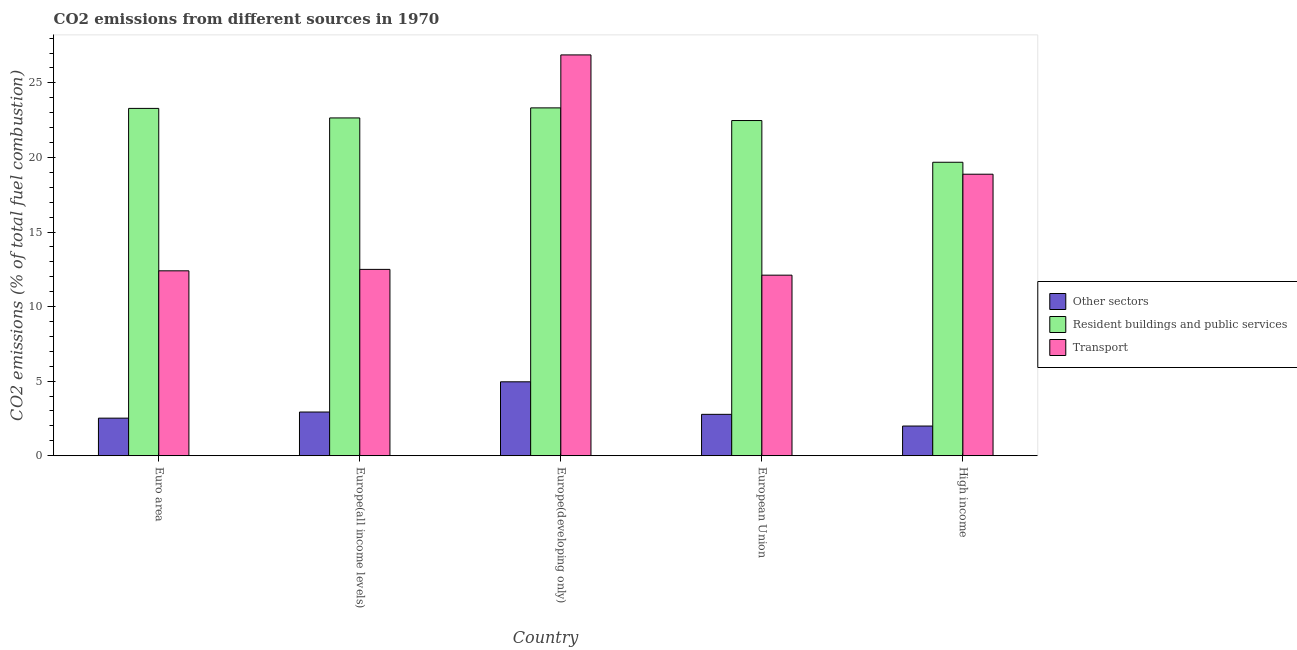How many bars are there on the 3rd tick from the left?
Give a very brief answer. 3. How many bars are there on the 3rd tick from the right?
Keep it short and to the point. 3. In how many cases, is the number of bars for a given country not equal to the number of legend labels?
Make the answer very short. 0. What is the percentage of co2 emissions from other sectors in Euro area?
Ensure brevity in your answer.  2.52. Across all countries, what is the maximum percentage of co2 emissions from transport?
Make the answer very short. 26.88. Across all countries, what is the minimum percentage of co2 emissions from other sectors?
Your answer should be compact. 1.99. In which country was the percentage of co2 emissions from other sectors maximum?
Give a very brief answer. Europe(developing only). In which country was the percentage of co2 emissions from other sectors minimum?
Keep it short and to the point. High income. What is the total percentage of co2 emissions from transport in the graph?
Provide a succinct answer. 82.75. What is the difference between the percentage of co2 emissions from other sectors in Euro area and that in Europe(all income levels)?
Offer a terse response. -0.41. What is the difference between the percentage of co2 emissions from resident buildings and public services in European Union and the percentage of co2 emissions from transport in Europe(all income levels)?
Ensure brevity in your answer.  9.98. What is the average percentage of co2 emissions from other sectors per country?
Keep it short and to the point. 3.03. What is the difference between the percentage of co2 emissions from resident buildings and public services and percentage of co2 emissions from transport in Europe(all income levels)?
Your answer should be compact. 10.16. What is the ratio of the percentage of co2 emissions from other sectors in European Union to that in High income?
Your response must be concise. 1.39. Is the percentage of co2 emissions from resident buildings and public services in Euro area less than that in Europe(developing only)?
Offer a terse response. Yes. Is the difference between the percentage of co2 emissions from resident buildings and public services in Europe(developing only) and European Union greater than the difference between the percentage of co2 emissions from transport in Europe(developing only) and European Union?
Your answer should be very brief. No. What is the difference between the highest and the second highest percentage of co2 emissions from transport?
Keep it short and to the point. 8. What is the difference between the highest and the lowest percentage of co2 emissions from resident buildings and public services?
Keep it short and to the point. 3.65. In how many countries, is the percentage of co2 emissions from resident buildings and public services greater than the average percentage of co2 emissions from resident buildings and public services taken over all countries?
Give a very brief answer. 4. Is the sum of the percentage of co2 emissions from other sectors in European Union and High income greater than the maximum percentage of co2 emissions from transport across all countries?
Your answer should be compact. No. What does the 1st bar from the left in Euro area represents?
Ensure brevity in your answer.  Other sectors. What does the 1st bar from the right in Europe(developing only) represents?
Offer a terse response. Transport. How many bars are there?
Your answer should be compact. 15. Are all the bars in the graph horizontal?
Keep it short and to the point. No. How many countries are there in the graph?
Provide a succinct answer. 5. Does the graph contain grids?
Offer a very short reply. No. Where does the legend appear in the graph?
Provide a succinct answer. Center right. How are the legend labels stacked?
Your answer should be very brief. Vertical. What is the title of the graph?
Ensure brevity in your answer.  CO2 emissions from different sources in 1970. Does "Grants" appear as one of the legend labels in the graph?
Offer a terse response. No. What is the label or title of the X-axis?
Your response must be concise. Country. What is the label or title of the Y-axis?
Keep it short and to the point. CO2 emissions (% of total fuel combustion). What is the CO2 emissions (% of total fuel combustion) of Other sectors in Euro area?
Your answer should be compact. 2.52. What is the CO2 emissions (% of total fuel combustion) of Resident buildings and public services in Euro area?
Make the answer very short. 23.29. What is the CO2 emissions (% of total fuel combustion) of Transport in Euro area?
Offer a very short reply. 12.4. What is the CO2 emissions (% of total fuel combustion) in Other sectors in Europe(all income levels)?
Give a very brief answer. 2.93. What is the CO2 emissions (% of total fuel combustion) in Resident buildings and public services in Europe(all income levels)?
Your answer should be compact. 22.65. What is the CO2 emissions (% of total fuel combustion) in Transport in Europe(all income levels)?
Provide a succinct answer. 12.49. What is the CO2 emissions (% of total fuel combustion) of Other sectors in Europe(developing only)?
Offer a very short reply. 4.96. What is the CO2 emissions (% of total fuel combustion) in Resident buildings and public services in Europe(developing only)?
Give a very brief answer. 23.32. What is the CO2 emissions (% of total fuel combustion) of Transport in Europe(developing only)?
Your answer should be compact. 26.88. What is the CO2 emissions (% of total fuel combustion) of Other sectors in European Union?
Offer a very short reply. 2.78. What is the CO2 emissions (% of total fuel combustion) of Resident buildings and public services in European Union?
Your response must be concise. 22.48. What is the CO2 emissions (% of total fuel combustion) of Transport in European Union?
Offer a terse response. 12.11. What is the CO2 emissions (% of total fuel combustion) in Other sectors in High income?
Offer a very short reply. 1.99. What is the CO2 emissions (% of total fuel combustion) of Resident buildings and public services in High income?
Provide a succinct answer. 19.68. What is the CO2 emissions (% of total fuel combustion) in Transport in High income?
Provide a short and direct response. 18.88. Across all countries, what is the maximum CO2 emissions (% of total fuel combustion) of Other sectors?
Your response must be concise. 4.96. Across all countries, what is the maximum CO2 emissions (% of total fuel combustion) in Resident buildings and public services?
Provide a succinct answer. 23.32. Across all countries, what is the maximum CO2 emissions (% of total fuel combustion) of Transport?
Your response must be concise. 26.88. Across all countries, what is the minimum CO2 emissions (% of total fuel combustion) in Other sectors?
Provide a short and direct response. 1.99. Across all countries, what is the minimum CO2 emissions (% of total fuel combustion) of Resident buildings and public services?
Your answer should be compact. 19.68. Across all countries, what is the minimum CO2 emissions (% of total fuel combustion) in Transport?
Your response must be concise. 12.11. What is the total CO2 emissions (% of total fuel combustion) in Other sectors in the graph?
Offer a very short reply. 15.17. What is the total CO2 emissions (% of total fuel combustion) in Resident buildings and public services in the graph?
Your answer should be compact. 111.42. What is the total CO2 emissions (% of total fuel combustion) in Transport in the graph?
Offer a very short reply. 82.75. What is the difference between the CO2 emissions (% of total fuel combustion) in Other sectors in Euro area and that in Europe(all income levels)?
Your response must be concise. -0.41. What is the difference between the CO2 emissions (% of total fuel combustion) in Resident buildings and public services in Euro area and that in Europe(all income levels)?
Provide a succinct answer. 0.64. What is the difference between the CO2 emissions (% of total fuel combustion) in Transport in Euro area and that in Europe(all income levels)?
Keep it short and to the point. -0.1. What is the difference between the CO2 emissions (% of total fuel combustion) of Other sectors in Euro area and that in Europe(developing only)?
Offer a terse response. -2.44. What is the difference between the CO2 emissions (% of total fuel combustion) in Resident buildings and public services in Euro area and that in Europe(developing only)?
Make the answer very short. -0.03. What is the difference between the CO2 emissions (% of total fuel combustion) of Transport in Euro area and that in Europe(developing only)?
Offer a terse response. -14.48. What is the difference between the CO2 emissions (% of total fuel combustion) of Other sectors in Euro area and that in European Union?
Your response must be concise. -0.26. What is the difference between the CO2 emissions (% of total fuel combustion) of Resident buildings and public services in Euro area and that in European Union?
Provide a short and direct response. 0.81. What is the difference between the CO2 emissions (% of total fuel combustion) of Transport in Euro area and that in European Union?
Your response must be concise. 0.29. What is the difference between the CO2 emissions (% of total fuel combustion) in Other sectors in Euro area and that in High income?
Provide a succinct answer. 0.53. What is the difference between the CO2 emissions (% of total fuel combustion) in Resident buildings and public services in Euro area and that in High income?
Offer a terse response. 3.61. What is the difference between the CO2 emissions (% of total fuel combustion) in Transport in Euro area and that in High income?
Make the answer very short. -6.48. What is the difference between the CO2 emissions (% of total fuel combustion) of Other sectors in Europe(all income levels) and that in Europe(developing only)?
Provide a short and direct response. -2.03. What is the difference between the CO2 emissions (% of total fuel combustion) in Resident buildings and public services in Europe(all income levels) and that in Europe(developing only)?
Offer a terse response. -0.67. What is the difference between the CO2 emissions (% of total fuel combustion) in Transport in Europe(all income levels) and that in Europe(developing only)?
Ensure brevity in your answer.  -14.38. What is the difference between the CO2 emissions (% of total fuel combustion) in Other sectors in Europe(all income levels) and that in European Union?
Offer a very short reply. 0.15. What is the difference between the CO2 emissions (% of total fuel combustion) of Resident buildings and public services in Europe(all income levels) and that in European Union?
Keep it short and to the point. 0.17. What is the difference between the CO2 emissions (% of total fuel combustion) in Transport in Europe(all income levels) and that in European Union?
Your answer should be very brief. 0.39. What is the difference between the CO2 emissions (% of total fuel combustion) in Other sectors in Europe(all income levels) and that in High income?
Your answer should be very brief. 0.94. What is the difference between the CO2 emissions (% of total fuel combustion) of Resident buildings and public services in Europe(all income levels) and that in High income?
Provide a succinct answer. 2.97. What is the difference between the CO2 emissions (% of total fuel combustion) in Transport in Europe(all income levels) and that in High income?
Your answer should be very brief. -6.38. What is the difference between the CO2 emissions (% of total fuel combustion) of Other sectors in Europe(developing only) and that in European Union?
Provide a short and direct response. 2.18. What is the difference between the CO2 emissions (% of total fuel combustion) of Resident buildings and public services in Europe(developing only) and that in European Union?
Provide a short and direct response. 0.85. What is the difference between the CO2 emissions (% of total fuel combustion) of Transport in Europe(developing only) and that in European Union?
Offer a terse response. 14.77. What is the difference between the CO2 emissions (% of total fuel combustion) in Other sectors in Europe(developing only) and that in High income?
Your answer should be compact. 2.97. What is the difference between the CO2 emissions (% of total fuel combustion) in Resident buildings and public services in Europe(developing only) and that in High income?
Keep it short and to the point. 3.65. What is the difference between the CO2 emissions (% of total fuel combustion) of Transport in Europe(developing only) and that in High income?
Provide a short and direct response. 8. What is the difference between the CO2 emissions (% of total fuel combustion) of Other sectors in European Union and that in High income?
Provide a short and direct response. 0.79. What is the difference between the CO2 emissions (% of total fuel combustion) in Resident buildings and public services in European Union and that in High income?
Your answer should be very brief. 2.8. What is the difference between the CO2 emissions (% of total fuel combustion) in Transport in European Union and that in High income?
Give a very brief answer. -6.77. What is the difference between the CO2 emissions (% of total fuel combustion) of Other sectors in Euro area and the CO2 emissions (% of total fuel combustion) of Resident buildings and public services in Europe(all income levels)?
Your response must be concise. -20.13. What is the difference between the CO2 emissions (% of total fuel combustion) in Other sectors in Euro area and the CO2 emissions (% of total fuel combustion) in Transport in Europe(all income levels)?
Offer a very short reply. -9.97. What is the difference between the CO2 emissions (% of total fuel combustion) of Resident buildings and public services in Euro area and the CO2 emissions (% of total fuel combustion) of Transport in Europe(all income levels)?
Your response must be concise. 10.79. What is the difference between the CO2 emissions (% of total fuel combustion) of Other sectors in Euro area and the CO2 emissions (% of total fuel combustion) of Resident buildings and public services in Europe(developing only)?
Keep it short and to the point. -20.8. What is the difference between the CO2 emissions (% of total fuel combustion) in Other sectors in Euro area and the CO2 emissions (% of total fuel combustion) in Transport in Europe(developing only)?
Offer a very short reply. -24.35. What is the difference between the CO2 emissions (% of total fuel combustion) of Resident buildings and public services in Euro area and the CO2 emissions (% of total fuel combustion) of Transport in Europe(developing only)?
Give a very brief answer. -3.59. What is the difference between the CO2 emissions (% of total fuel combustion) of Other sectors in Euro area and the CO2 emissions (% of total fuel combustion) of Resident buildings and public services in European Union?
Give a very brief answer. -19.96. What is the difference between the CO2 emissions (% of total fuel combustion) of Other sectors in Euro area and the CO2 emissions (% of total fuel combustion) of Transport in European Union?
Provide a succinct answer. -9.59. What is the difference between the CO2 emissions (% of total fuel combustion) of Resident buildings and public services in Euro area and the CO2 emissions (% of total fuel combustion) of Transport in European Union?
Make the answer very short. 11.18. What is the difference between the CO2 emissions (% of total fuel combustion) in Other sectors in Euro area and the CO2 emissions (% of total fuel combustion) in Resident buildings and public services in High income?
Offer a very short reply. -17.16. What is the difference between the CO2 emissions (% of total fuel combustion) of Other sectors in Euro area and the CO2 emissions (% of total fuel combustion) of Transport in High income?
Provide a short and direct response. -16.36. What is the difference between the CO2 emissions (% of total fuel combustion) of Resident buildings and public services in Euro area and the CO2 emissions (% of total fuel combustion) of Transport in High income?
Keep it short and to the point. 4.41. What is the difference between the CO2 emissions (% of total fuel combustion) of Other sectors in Europe(all income levels) and the CO2 emissions (% of total fuel combustion) of Resident buildings and public services in Europe(developing only)?
Offer a terse response. -20.39. What is the difference between the CO2 emissions (% of total fuel combustion) in Other sectors in Europe(all income levels) and the CO2 emissions (% of total fuel combustion) in Transport in Europe(developing only)?
Provide a short and direct response. -23.95. What is the difference between the CO2 emissions (% of total fuel combustion) of Resident buildings and public services in Europe(all income levels) and the CO2 emissions (% of total fuel combustion) of Transport in Europe(developing only)?
Keep it short and to the point. -4.23. What is the difference between the CO2 emissions (% of total fuel combustion) in Other sectors in Europe(all income levels) and the CO2 emissions (% of total fuel combustion) in Resident buildings and public services in European Union?
Offer a very short reply. -19.55. What is the difference between the CO2 emissions (% of total fuel combustion) in Other sectors in Europe(all income levels) and the CO2 emissions (% of total fuel combustion) in Transport in European Union?
Provide a succinct answer. -9.18. What is the difference between the CO2 emissions (% of total fuel combustion) of Resident buildings and public services in Europe(all income levels) and the CO2 emissions (% of total fuel combustion) of Transport in European Union?
Provide a succinct answer. 10.54. What is the difference between the CO2 emissions (% of total fuel combustion) of Other sectors in Europe(all income levels) and the CO2 emissions (% of total fuel combustion) of Resident buildings and public services in High income?
Your answer should be compact. -16.75. What is the difference between the CO2 emissions (% of total fuel combustion) of Other sectors in Europe(all income levels) and the CO2 emissions (% of total fuel combustion) of Transport in High income?
Offer a terse response. -15.95. What is the difference between the CO2 emissions (% of total fuel combustion) of Resident buildings and public services in Europe(all income levels) and the CO2 emissions (% of total fuel combustion) of Transport in High income?
Ensure brevity in your answer.  3.77. What is the difference between the CO2 emissions (% of total fuel combustion) in Other sectors in Europe(developing only) and the CO2 emissions (% of total fuel combustion) in Resident buildings and public services in European Union?
Make the answer very short. -17.52. What is the difference between the CO2 emissions (% of total fuel combustion) of Other sectors in Europe(developing only) and the CO2 emissions (% of total fuel combustion) of Transport in European Union?
Keep it short and to the point. -7.15. What is the difference between the CO2 emissions (% of total fuel combustion) of Resident buildings and public services in Europe(developing only) and the CO2 emissions (% of total fuel combustion) of Transport in European Union?
Make the answer very short. 11.22. What is the difference between the CO2 emissions (% of total fuel combustion) of Other sectors in Europe(developing only) and the CO2 emissions (% of total fuel combustion) of Resident buildings and public services in High income?
Your answer should be very brief. -14.72. What is the difference between the CO2 emissions (% of total fuel combustion) of Other sectors in Europe(developing only) and the CO2 emissions (% of total fuel combustion) of Transport in High income?
Your response must be concise. -13.92. What is the difference between the CO2 emissions (% of total fuel combustion) in Resident buildings and public services in Europe(developing only) and the CO2 emissions (% of total fuel combustion) in Transport in High income?
Offer a very short reply. 4.45. What is the difference between the CO2 emissions (% of total fuel combustion) of Other sectors in European Union and the CO2 emissions (% of total fuel combustion) of Resident buildings and public services in High income?
Make the answer very short. -16.9. What is the difference between the CO2 emissions (% of total fuel combustion) of Other sectors in European Union and the CO2 emissions (% of total fuel combustion) of Transport in High income?
Ensure brevity in your answer.  -16.1. What is the difference between the CO2 emissions (% of total fuel combustion) of Resident buildings and public services in European Union and the CO2 emissions (% of total fuel combustion) of Transport in High income?
Provide a succinct answer. 3.6. What is the average CO2 emissions (% of total fuel combustion) of Other sectors per country?
Offer a terse response. 3.03. What is the average CO2 emissions (% of total fuel combustion) of Resident buildings and public services per country?
Offer a very short reply. 22.28. What is the average CO2 emissions (% of total fuel combustion) of Transport per country?
Make the answer very short. 16.55. What is the difference between the CO2 emissions (% of total fuel combustion) of Other sectors and CO2 emissions (% of total fuel combustion) of Resident buildings and public services in Euro area?
Provide a short and direct response. -20.77. What is the difference between the CO2 emissions (% of total fuel combustion) in Other sectors and CO2 emissions (% of total fuel combustion) in Transport in Euro area?
Offer a terse response. -9.88. What is the difference between the CO2 emissions (% of total fuel combustion) in Resident buildings and public services and CO2 emissions (% of total fuel combustion) in Transport in Euro area?
Your response must be concise. 10.89. What is the difference between the CO2 emissions (% of total fuel combustion) in Other sectors and CO2 emissions (% of total fuel combustion) in Resident buildings and public services in Europe(all income levels)?
Provide a short and direct response. -19.72. What is the difference between the CO2 emissions (% of total fuel combustion) in Other sectors and CO2 emissions (% of total fuel combustion) in Transport in Europe(all income levels)?
Your response must be concise. -9.56. What is the difference between the CO2 emissions (% of total fuel combustion) in Resident buildings and public services and CO2 emissions (% of total fuel combustion) in Transport in Europe(all income levels)?
Offer a terse response. 10.16. What is the difference between the CO2 emissions (% of total fuel combustion) in Other sectors and CO2 emissions (% of total fuel combustion) in Resident buildings and public services in Europe(developing only)?
Provide a short and direct response. -18.37. What is the difference between the CO2 emissions (% of total fuel combustion) in Other sectors and CO2 emissions (% of total fuel combustion) in Transport in Europe(developing only)?
Give a very brief answer. -21.92. What is the difference between the CO2 emissions (% of total fuel combustion) of Resident buildings and public services and CO2 emissions (% of total fuel combustion) of Transport in Europe(developing only)?
Your answer should be compact. -3.55. What is the difference between the CO2 emissions (% of total fuel combustion) in Other sectors and CO2 emissions (% of total fuel combustion) in Resident buildings and public services in European Union?
Make the answer very short. -19.7. What is the difference between the CO2 emissions (% of total fuel combustion) of Other sectors and CO2 emissions (% of total fuel combustion) of Transport in European Union?
Your response must be concise. -9.33. What is the difference between the CO2 emissions (% of total fuel combustion) of Resident buildings and public services and CO2 emissions (% of total fuel combustion) of Transport in European Union?
Your answer should be compact. 10.37. What is the difference between the CO2 emissions (% of total fuel combustion) of Other sectors and CO2 emissions (% of total fuel combustion) of Resident buildings and public services in High income?
Your answer should be very brief. -17.69. What is the difference between the CO2 emissions (% of total fuel combustion) in Other sectors and CO2 emissions (% of total fuel combustion) in Transport in High income?
Give a very brief answer. -16.89. What is the difference between the CO2 emissions (% of total fuel combustion) of Resident buildings and public services and CO2 emissions (% of total fuel combustion) of Transport in High income?
Offer a very short reply. 0.8. What is the ratio of the CO2 emissions (% of total fuel combustion) of Other sectors in Euro area to that in Europe(all income levels)?
Give a very brief answer. 0.86. What is the ratio of the CO2 emissions (% of total fuel combustion) of Resident buildings and public services in Euro area to that in Europe(all income levels)?
Provide a short and direct response. 1.03. What is the ratio of the CO2 emissions (% of total fuel combustion) of Other sectors in Euro area to that in Europe(developing only)?
Provide a succinct answer. 0.51. What is the ratio of the CO2 emissions (% of total fuel combustion) of Transport in Euro area to that in Europe(developing only)?
Your answer should be compact. 0.46. What is the ratio of the CO2 emissions (% of total fuel combustion) in Other sectors in Euro area to that in European Union?
Your response must be concise. 0.91. What is the ratio of the CO2 emissions (% of total fuel combustion) of Resident buildings and public services in Euro area to that in European Union?
Offer a terse response. 1.04. What is the ratio of the CO2 emissions (% of total fuel combustion) of Transport in Euro area to that in European Union?
Ensure brevity in your answer.  1.02. What is the ratio of the CO2 emissions (% of total fuel combustion) in Other sectors in Euro area to that in High income?
Offer a very short reply. 1.27. What is the ratio of the CO2 emissions (% of total fuel combustion) in Resident buildings and public services in Euro area to that in High income?
Offer a terse response. 1.18. What is the ratio of the CO2 emissions (% of total fuel combustion) of Transport in Euro area to that in High income?
Provide a short and direct response. 0.66. What is the ratio of the CO2 emissions (% of total fuel combustion) of Other sectors in Europe(all income levels) to that in Europe(developing only)?
Offer a terse response. 0.59. What is the ratio of the CO2 emissions (% of total fuel combustion) of Resident buildings and public services in Europe(all income levels) to that in Europe(developing only)?
Ensure brevity in your answer.  0.97. What is the ratio of the CO2 emissions (% of total fuel combustion) in Transport in Europe(all income levels) to that in Europe(developing only)?
Give a very brief answer. 0.46. What is the ratio of the CO2 emissions (% of total fuel combustion) of Other sectors in Europe(all income levels) to that in European Union?
Make the answer very short. 1.06. What is the ratio of the CO2 emissions (% of total fuel combustion) of Resident buildings and public services in Europe(all income levels) to that in European Union?
Offer a very short reply. 1.01. What is the ratio of the CO2 emissions (% of total fuel combustion) of Transport in Europe(all income levels) to that in European Union?
Your answer should be compact. 1.03. What is the ratio of the CO2 emissions (% of total fuel combustion) of Other sectors in Europe(all income levels) to that in High income?
Provide a short and direct response. 1.47. What is the ratio of the CO2 emissions (% of total fuel combustion) of Resident buildings and public services in Europe(all income levels) to that in High income?
Offer a terse response. 1.15. What is the ratio of the CO2 emissions (% of total fuel combustion) in Transport in Europe(all income levels) to that in High income?
Provide a short and direct response. 0.66. What is the ratio of the CO2 emissions (% of total fuel combustion) of Other sectors in Europe(developing only) to that in European Union?
Offer a terse response. 1.79. What is the ratio of the CO2 emissions (% of total fuel combustion) in Resident buildings and public services in Europe(developing only) to that in European Union?
Your answer should be compact. 1.04. What is the ratio of the CO2 emissions (% of total fuel combustion) of Transport in Europe(developing only) to that in European Union?
Provide a short and direct response. 2.22. What is the ratio of the CO2 emissions (% of total fuel combustion) in Other sectors in Europe(developing only) to that in High income?
Keep it short and to the point. 2.49. What is the ratio of the CO2 emissions (% of total fuel combustion) of Resident buildings and public services in Europe(developing only) to that in High income?
Keep it short and to the point. 1.19. What is the ratio of the CO2 emissions (% of total fuel combustion) in Transport in Europe(developing only) to that in High income?
Ensure brevity in your answer.  1.42. What is the ratio of the CO2 emissions (% of total fuel combustion) of Other sectors in European Union to that in High income?
Keep it short and to the point. 1.39. What is the ratio of the CO2 emissions (% of total fuel combustion) in Resident buildings and public services in European Union to that in High income?
Provide a succinct answer. 1.14. What is the ratio of the CO2 emissions (% of total fuel combustion) in Transport in European Union to that in High income?
Your answer should be very brief. 0.64. What is the difference between the highest and the second highest CO2 emissions (% of total fuel combustion) of Other sectors?
Your answer should be compact. 2.03. What is the difference between the highest and the second highest CO2 emissions (% of total fuel combustion) of Resident buildings and public services?
Give a very brief answer. 0.03. What is the difference between the highest and the second highest CO2 emissions (% of total fuel combustion) of Transport?
Your answer should be compact. 8. What is the difference between the highest and the lowest CO2 emissions (% of total fuel combustion) in Other sectors?
Your response must be concise. 2.97. What is the difference between the highest and the lowest CO2 emissions (% of total fuel combustion) in Resident buildings and public services?
Ensure brevity in your answer.  3.65. What is the difference between the highest and the lowest CO2 emissions (% of total fuel combustion) of Transport?
Ensure brevity in your answer.  14.77. 